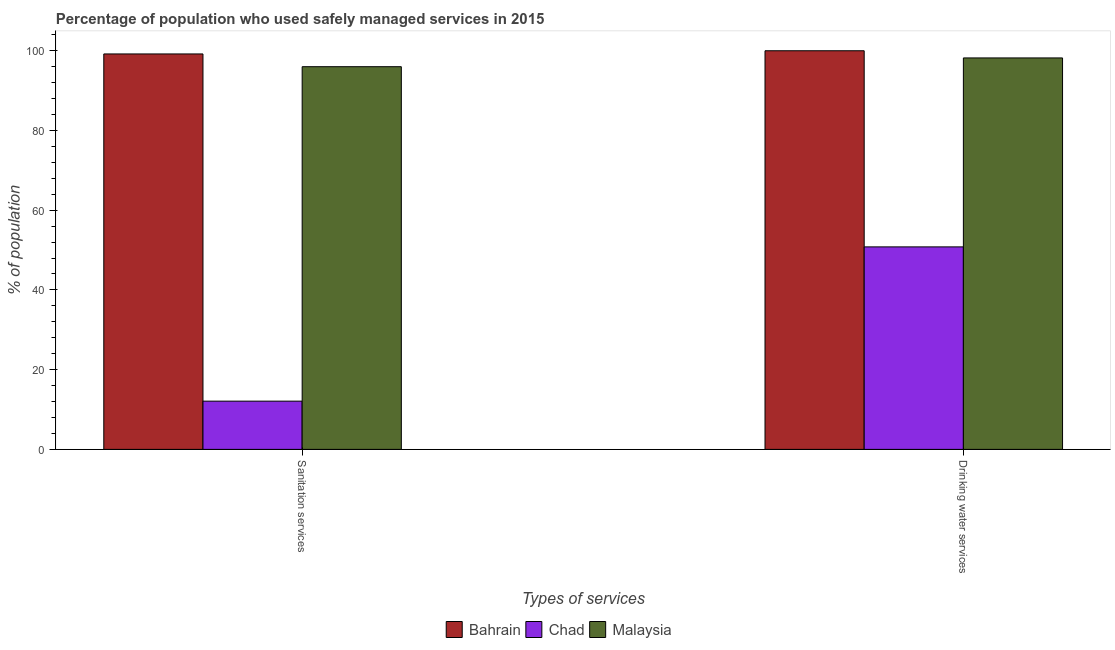How many different coloured bars are there?
Keep it short and to the point. 3. Are the number of bars per tick equal to the number of legend labels?
Make the answer very short. Yes. Are the number of bars on each tick of the X-axis equal?
Your answer should be very brief. Yes. How many bars are there on the 2nd tick from the right?
Your answer should be compact. 3. What is the label of the 2nd group of bars from the left?
Give a very brief answer. Drinking water services. What is the percentage of population who used sanitation services in Bahrain?
Ensure brevity in your answer.  99.2. Across all countries, what is the maximum percentage of population who used sanitation services?
Provide a short and direct response. 99.2. Across all countries, what is the minimum percentage of population who used sanitation services?
Your answer should be very brief. 12.1. In which country was the percentage of population who used drinking water services maximum?
Your response must be concise. Bahrain. In which country was the percentage of population who used sanitation services minimum?
Keep it short and to the point. Chad. What is the total percentage of population who used sanitation services in the graph?
Your response must be concise. 207.3. What is the difference between the percentage of population who used drinking water services in Malaysia and that in Bahrain?
Give a very brief answer. -1.8. What is the difference between the percentage of population who used drinking water services in Bahrain and the percentage of population who used sanitation services in Chad?
Provide a succinct answer. 87.9. What is the average percentage of population who used sanitation services per country?
Provide a short and direct response. 69.1. What is the difference between the percentage of population who used drinking water services and percentage of population who used sanitation services in Chad?
Provide a short and direct response. 38.7. What is the ratio of the percentage of population who used sanitation services in Chad to that in Malaysia?
Make the answer very short. 0.13. Is the percentage of population who used sanitation services in Malaysia less than that in Chad?
Keep it short and to the point. No. In how many countries, is the percentage of population who used sanitation services greater than the average percentage of population who used sanitation services taken over all countries?
Provide a short and direct response. 2. What does the 1st bar from the left in Drinking water services represents?
Give a very brief answer. Bahrain. What does the 3rd bar from the right in Sanitation services represents?
Your response must be concise. Bahrain. How many bars are there?
Keep it short and to the point. 6. Are all the bars in the graph horizontal?
Keep it short and to the point. No. How many countries are there in the graph?
Keep it short and to the point. 3. What is the difference between two consecutive major ticks on the Y-axis?
Offer a very short reply. 20. Does the graph contain grids?
Your answer should be compact. No. How are the legend labels stacked?
Your answer should be very brief. Horizontal. What is the title of the graph?
Offer a very short reply. Percentage of population who used safely managed services in 2015. Does "Mexico" appear as one of the legend labels in the graph?
Your response must be concise. No. What is the label or title of the X-axis?
Your response must be concise. Types of services. What is the label or title of the Y-axis?
Ensure brevity in your answer.  % of population. What is the % of population in Bahrain in Sanitation services?
Provide a succinct answer. 99.2. What is the % of population of Malaysia in Sanitation services?
Ensure brevity in your answer.  96. What is the % of population in Chad in Drinking water services?
Ensure brevity in your answer.  50.8. What is the % of population in Malaysia in Drinking water services?
Your answer should be compact. 98.2. Across all Types of services, what is the maximum % of population of Chad?
Provide a succinct answer. 50.8. Across all Types of services, what is the maximum % of population of Malaysia?
Give a very brief answer. 98.2. Across all Types of services, what is the minimum % of population of Bahrain?
Offer a terse response. 99.2. Across all Types of services, what is the minimum % of population of Chad?
Ensure brevity in your answer.  12.1. Across all Types of services, what is the minimum % of population in Malaysia?
Provide a short and direct response. 96. What is the total % of population of Bahrain in the graph?
Your answer should be compact. 199.2. What is the total % of population of Chad in the graph?
Your answer should be very brief. 62.9. What is the total % of population in Malaysia in the graph?
Your answer should be compact. 194.2. What is the difference between the % of population in Bahrain in Sanitation services and that in Drinking water services?
Offer a very short reply. -0.8. What is the difference between the % of population in Chad in Sanitation services and that in Drinking water services?
Give a very brief answer. -38.7. What is the difference between the % of population of Malaysia in Sanitation services and that in Drinking water services?
Make the answer very short. -2.2. What is the difference between the % of population of Bahrain in Sanitation services and the % of population of Chad in Drinking water services?
Offer a very short reply. 48.4. What is the difference between the % of population of Chad in Sanitation services and the % of population of Malaysia in Drinking water services?
Offer a terse response. -86.1. What is the average % of population in Bahrain per Types of services?
Provide a succinct answer. 99.6. What is the average % of population of Chad per Types of services?
Offer a very short reply. 31.45. What is the average % of population in Malaysia per Types of services?
Give a very brief answer. 97.1. What is the difference between the % of population in Bahrain and % of population in Chad in Sanitation services?
Ensure brevity in your answer.  87.1. What is the difference between the % of population in Chad and % of population in Malaysia in Sanitation services?
Make the answer very short. -83.9. What is the difference between the % of population in Bahrain and % of population in Chad in Drinking water services?
Your answer should be very brief. 49.2. What is the difference between the % of population of Bahrain and % of population of Malaysia in Drinking water services?
Your response must be concise. 1.8. What is the difference between the % of population of Chad and % of population of Malaysia in Drinking water services?
Offer a very short reply. -47.4. What is the ratio of the % of population in Bahrain in Sanitation services to that in Drinking water services?
Provide a succinct answer. 0.99. What is the ratio of the % of population of Chad in Sanitation services to that in Drinking water services?
Offer a very short reply. 0.24. What is the ratio of the % of population in Malaysia in Sanitation services to that in Drinking water services?
Offer a terse response. 0.98. What is the difference between the highest and the second highest % of population in Chad?
Provide a short and direct response. 38.7. What is the difference between the highest and the lowest % of population in Bahrain?
Provide a short and direct response. 0.8. What is the difference between the highest and the lowest % of population of Chad?
Your answer should be compact. 38.7. 